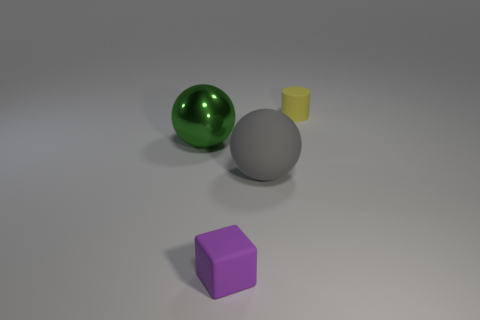What could be the potential use of these objects in a real-world scenario? The objects in the image appear to be simplistic models often used for illustrative purposes. The green sphere could represent a decorative item, the purple cube might be a toy block, the gray sphere could be a model for a ball bearing, and the yellow cylinder could resemble a cup or container. How do the textures of the objects differ? The textures vary: the green sphere has a reflective, shiny texture, suggesting a smooth and possibly metallic surface. The matte surfaces of the purple cube and gray sphere imply a more diffuse reflection, giving them a softer appearance. The yellow cylinder also has a matte finish, but its small size makes the texture less discernible compared to the other objects. 